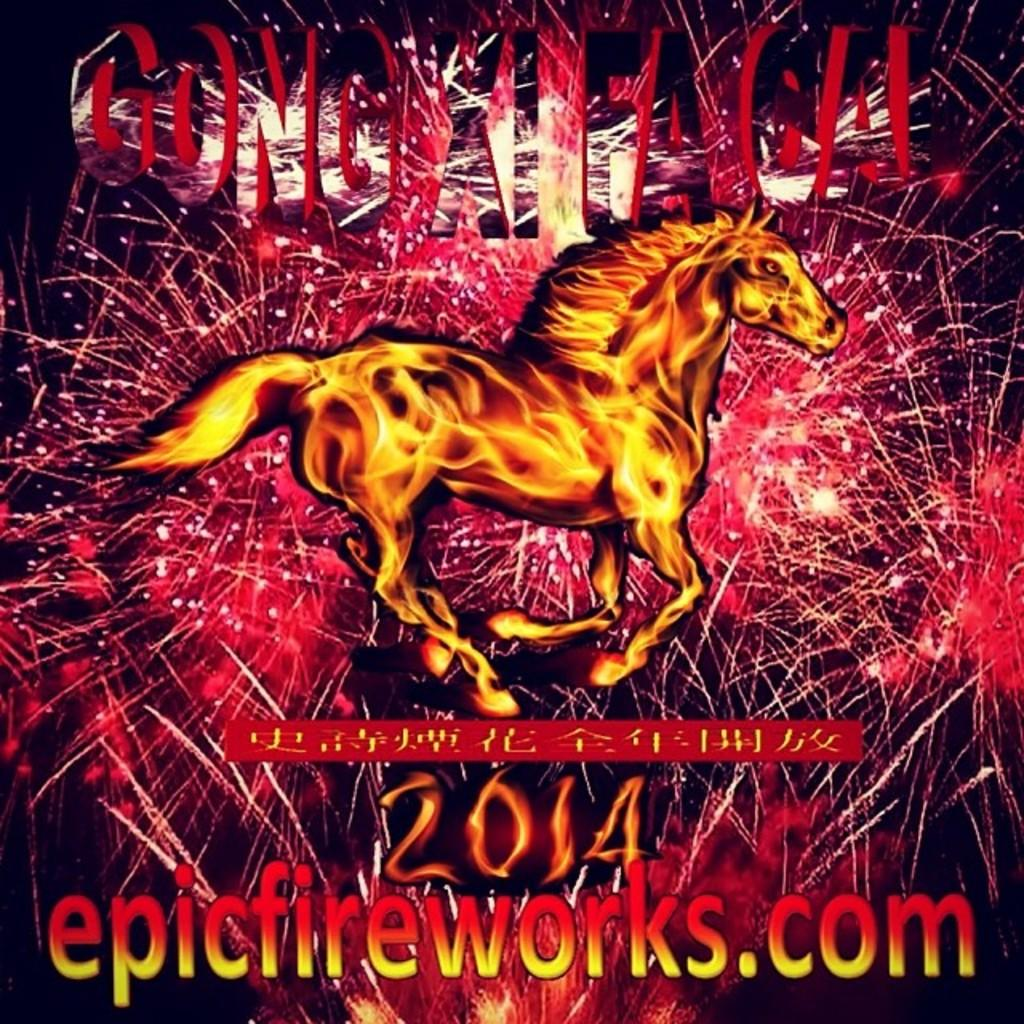What type of image is being described? The image is a poster. What is depicted on the poster? There is a horse on the poster. Are there any additional features on the poster? Yes, there is a watermark on the poster. How does the horse feel about rain in the image? There is no indication of the horse's feelings about rain in the image, as it is a static poster. Is there an oven visible in the image? No, there is no oven present in the image. 